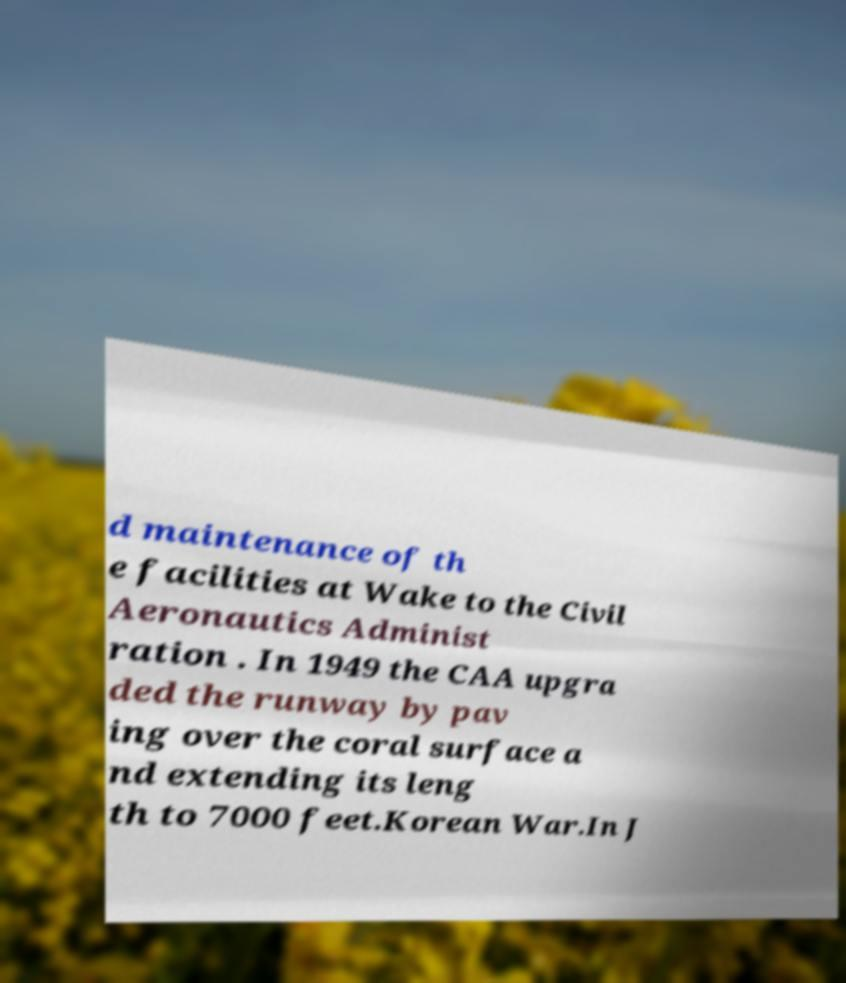There's text embedded in this image that I need extracted. Can you transcribe it verbatim? d maintenance of th e facilities at Wake to the Civil Aeronautics Administ ration . In 1949 the CAA upgra ded the runway by pav ing over the coral surface a nd extending its leng th to 7000 feet.Korean War.In J 